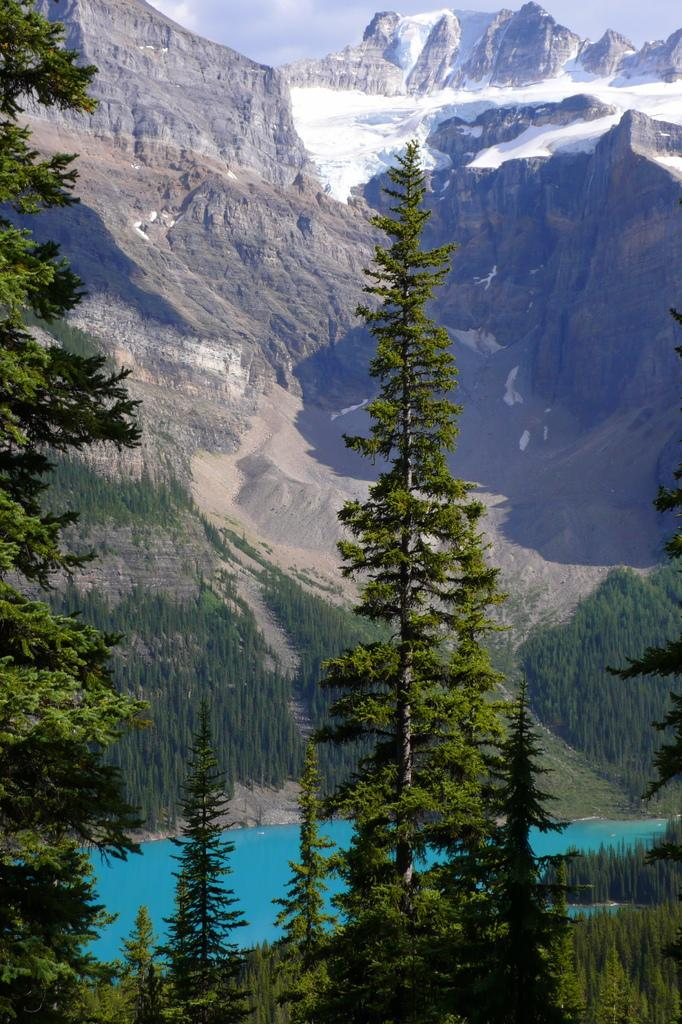What type of vegetation can be seen in the image? There are trees in the image. What is located at the bottom of the image? There is water at the bottom of the image. What geographical feature is visible in the background of the image? There is a mountain visible in the background of the image. What is visible at the top of the image? The sky is visible at the top of the image. Can you tell me how many glasses of wine are on the table in the image? There is no table or wine present in the image; it features trees, water, a mountain, and the sky. What type of sand can be seen on the beach in the image? There is no beach or sand present in the image. 